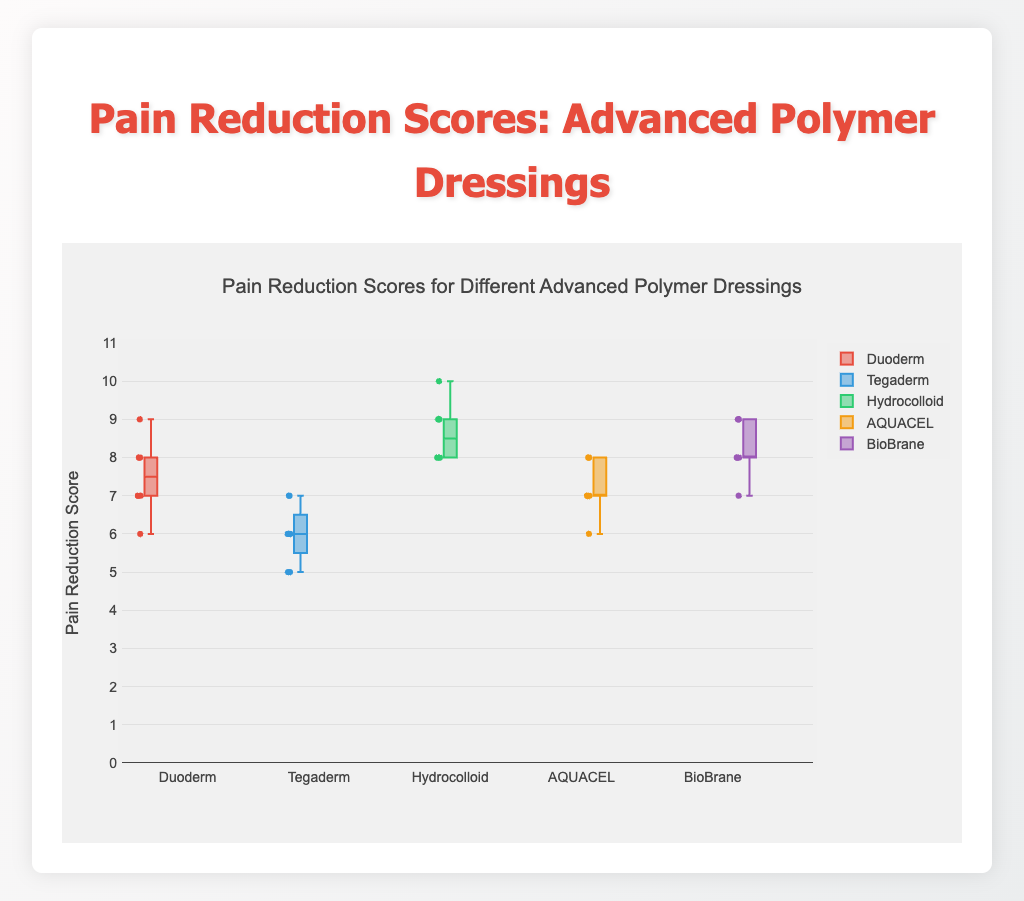What does the box plot's title indicate? The title of the box plot is "Pain Reduction Scores for Different Advanced Polymer Dressings", which informs us that the plot is comparing pain reduction scores among various types of advanced polymer dressings.
Answer: Pain Reduction Scores for Different Advanced Polymer Dressings Which dressing has the highest median pain reduction score? To determine the dressing with the highest median pain reduction score, one would look for the box plot where the line inside the box (median) is at the highest value on the y-axis. The Hydrocolloid dressing has the highest median pain reduction score.
Answer: Hydrocolloid How many data points are plotted for Tegaderm? Each data point is represented by an individual marker in the box plot. Count these markers for Tegaderm to find the total number.
Answer: 8 What is the range of pain reduction scores for BioBrane? The range is calculated by subtracting the minimum value from the maximum value, determined by looking at the whiskers of the BioBrane box plot (highest score is 9, lowest score is 7). Therefore, the range is 9 - 7 = 2.
Answer: 2 Which dressings have outliers? Outliers in a box plot are points that lie outside the whiskers or the general distribution range. From the box plots shown, no dressings appear to have outliers as all points are within the whiskers.
Answer: None Which dressing has the lowest minimum score? To find the dressing with the lowest minimum score, look at the lowest point on the whisker plot of each dressing. The Tegaderm dressing has the lowest minimum score of 5.
Answer: Tegaderm Compare the interquartile range (IQR) of Duoderm and AQUACEL. Which is larger? The IQR is the difference between the third quartile (75th percentile) and the first quartile (25th percentile). By observing the length of the box between the two quartiles: both Duoderm and AQUACEL look to have similar IQR since their boxes span similar lengths along the y-axis.
Answer: Both are similar Which dressing shows the least variability in pain reduction scores? Variability in a box plot is indicated by the length of the box and whiskers. AQUACEL shows the least variability as its box and whiskers span the shortest range on the y-axis.
Answer: AQUACEL What is the median pain reduction score for Duoderm? The median score is represented by the line inside the box of the Duoderm plot. This median value is 7.
Answer: 7 Is there any dressing that consistently scores 8 or above? To check consistency, we look at all data points above or at 8: Hydrocolloid has only scores that are 8 or above as all points lie at or above the 8 mark.
Answer: Hydrocolloid 